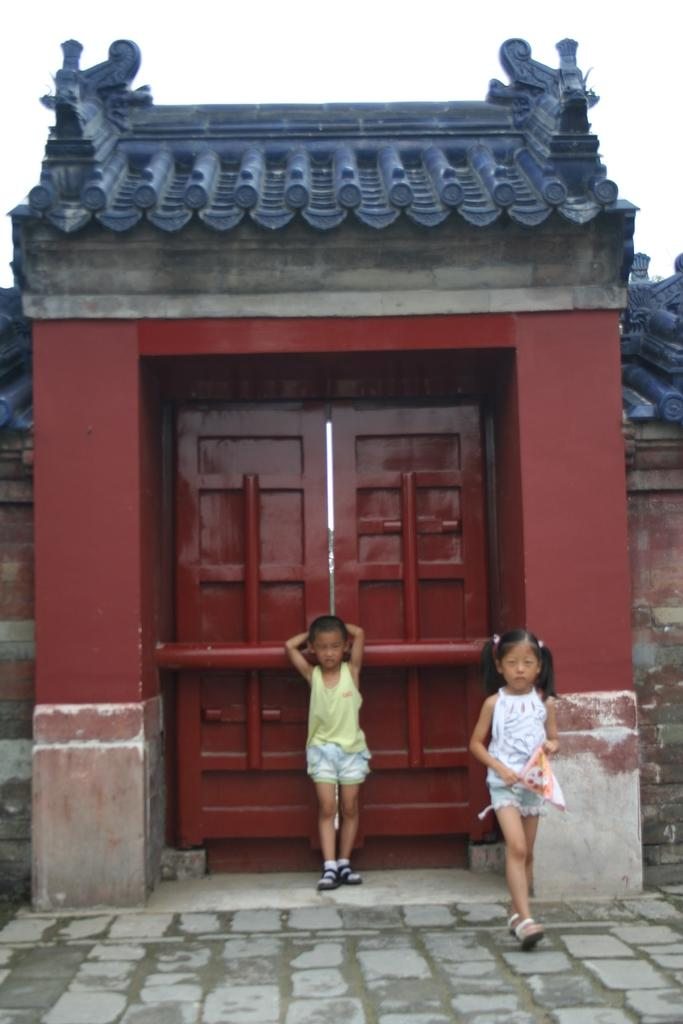What structure is present in the image? There is a door in the image. What is happening in front of the door? Two kids are standing in front of the door. What type of songs can be heard coming from the sky in the image? There is no reference to songs or the sky in the image, so it's not possible to determine what, if any, songs might be heard. 